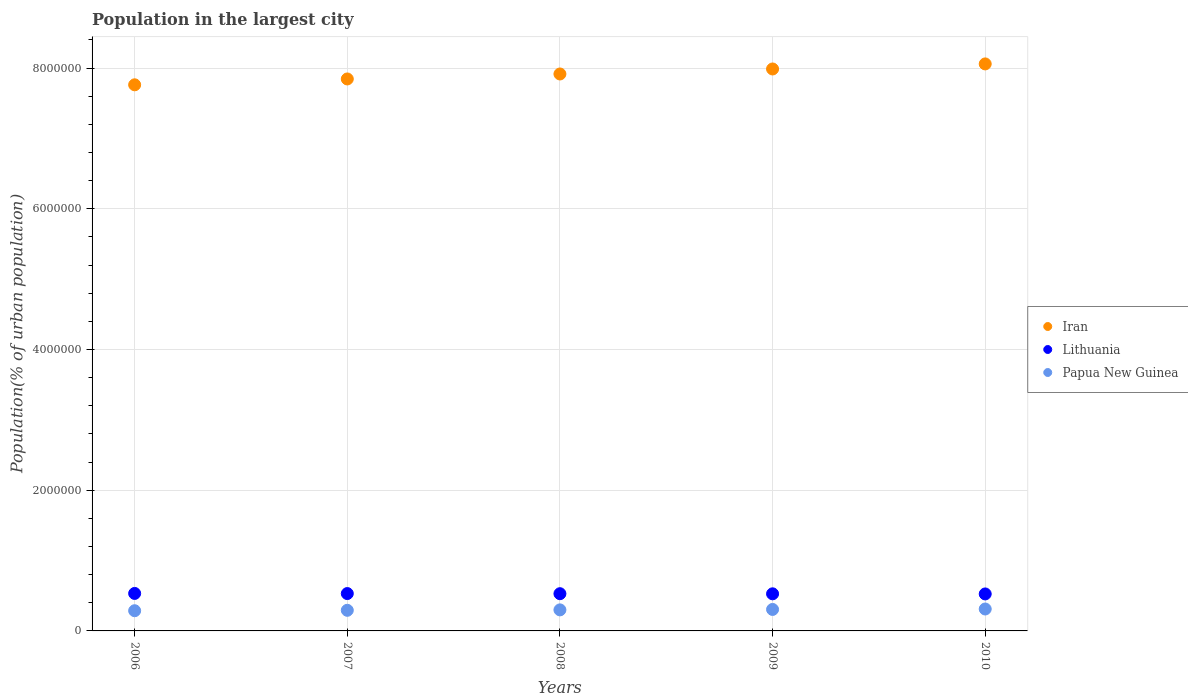Is the number of dotlines equal to the number of legend labels?
Give a very brief answer. Yes. What is the population in the largest city in Lithuania in 2006?
Offer a very short reply. 5.33e+05. Across all years, what is the maximum population in the largest city in Iran?
Offer a terse response. 8.06e+06. Across all years, what is the minimum population in the largest city in Iran?
Your response must be concise. 7.76e+06. In which year was the population in the largest city in Iran maximum?
Give a very brief answer. 2010. In which year was the population in the largest city in Lithuania minimum?
Make the answer very short. 2010. What is the total population in the largest city in Papua New Guinea in the graph?
Offer a very short reply. 1.50e+06. What is the difference between the population in the largest city in Iran in 2007 and that in 2009?
Your response must be concise. -1.42e+05. What is the difference between the population in the largest city in Lithuania in 2006 and the population in the largest city in Iran in 2007?
Provide a short and direct response. -7.31e+06. What is the average population in the largest city in Papua New Guinea per year?
Offer a very short reply. 2.99e+05. In the year 2010, what is the difference between the population in the largest city in Lithuania and population in the largest city in Iran?
Give a very brief answer. -7.53e+06. In how many years, is the population in the largest city in Iran greater than 800000 %?
Make the answer very short. 5. What is the ratio of the population in the largest city in Lithuania in 2009 to that in 2010?
Offer a terse response. 1. Is the population in the largest city in Lithuania in 2008 less than that in 2009?
Provide a succinct answer. No. What is the difference between the highest and the second highest population in the largest city in Lithuania?
Keep it short and to the point. 1802. What is the difference between the highest and the lowest population in the largest city in Papua New Guinea?
Your answer should be very brief. 2.44e+04. Is the sum of the population in the largest city in Lithuania in 2006 and 2009 greater than the maximum population in the largest city in Iran across all years?
Provide a short and direct response. No. Is it the case that in every year, the sum of the population in the largest city in Lithuania and population in the largest city in Iran  is greater than the population in the largest city in Papua New Guinea?
Keep it short and to the point. Yes. Is the population in the largest city in Papua New Guinea strictly less than the population in the largest city in Iran over the years?
Ensure brevity in your answer.  Yes. How many dotlines are there?
Offer a very short reply. 3. What is the difference between two consecutive major ticks on the Y-axis?
Your response must be concise. 2.00e+06. Are the values on the major ticks of Y-axis written in scientific E-notation?
Your answer should be compact. No. Does the graph contain any zero values?
Provide a short and direct response. No. Does the graph contain grids?
Your response must be concise. Yes. How many legend labels are there?
Give a very brief answer. 3. How are the legend labels stacked?
Provide a succinct answer. Vertical. What is the title of the graph?
Make the answer very short. Population in the largest city. Does "Norway" appear as one of the legend labels in the graph?
Your answer should be very brief. No. What is the label or title of the X-axis?
Provide a succinct answer. Years. What is the label or title of the Y-axis?
Your answer should be very brief. Population(% of urban population). What is the Population(% of urban population) of Iran in 2006?
Your answer should be very brief. 7.76e+06. What is the Population(% of urban population) in Lithuania in 2006?
Your answer should be very brief. 5.33e+05. What is the Population(% of urban population) in Papua New Guinea in 2006?
Ensure brevity in your answer.  2.87e+05. What is the Population(% of urban population) of Iran in 2007?
Keep it short and to the point. 7.84e+06. What is the Population(% of urban population) in Lithuania in 2007?
Provide a succinct answer. 5.31e+05. What is the Population(% of urban population) of Papua New Guinea in 2007?
Make the answer very short. 2.93e+05. What is the Population(% of urban population) in Iran in 2008?
Your answer should be very brief. 7.92e+06. What is the Population(% of urban population) of Lithuania in 2008?
Provide a short and direct response. 5.29e+05. What is the Population(% of urban population) of Papua New Guinea in 2008?
Your answer should be very brief. 2.99e+05. What is the Population(% of urban population) of Iran in 2009?
Keep it short and to the point. 7.99e+06. What is the Population(% of urban population) in Lithuania in 2009?
Your answer should be compact. 5.27e+05. What is the Population(% of urban population) of Papua New Guinea in 2009?
Make the answer very short. 3.05e+05. What is the Population(% of urban population) in Iran in 2010?
Provide a short and direct response. 8.06e+06. What is the Population(% of urban population) in Lithuania in 2010?
Your answer should be very brief. 5.26e+05. What is the Population(% of urban population) in Papua New Guinea in 2010?
Make the answer very short. 3.12e+05. Across all years, what is the maximum Population(% of urban population) of Iran?
Offer a very short reply. 8.06e+06. Across all years, what is the maximum Population(% of urban population) in Lithuania?
Give a very brief answer. 5.33e+05. Across all years, what is the maximum Population(% of urban population) of Papua New Guinea?
Your answer should be very brief. 3.12e+05. Across all years, what is the minimum Population(% of urban population) in Iran?
Offer a very short reply. 7.76e+06. Across all years, what is the minimum Population(% of urban population) in Lithuania?
Your answer should be very brief. 5.26e+05. Across all years, what is the minimum Population(% of urban population) in Papua New Guinea?
Keep it short and to the point. 2.87e+05. What is the total Population(% of urban population) in Iran in the graph?
Ensure brevity in your answer.  3.96e+07. What is the total Population(% of urban population) in Lithuania in the graph?
Provide a succinct answer. 2.65e+06. What is the total Population(% of urban population) of Papua New Guinea in the graph?
Your answer should be compact. 1.50e+06. What is the difference between the Population(% of urban population) of Iran in 2006 and that in 2007?
Your answer should be compact. -8.32e+04. What is the difference between the Population(% of urban population) of Lithuania in 2006 and that in 2007?
Offer a very short reply. 1802. What is the difference between the Population(% of urban population) of Papua New Guinea in 2006 and that in 2007?
Provide a succinct answer. -5919. What is the difference between the Population(% of urban population) in Iran in 2006 and that in 2008?
Keep it short and to the point. -1.54e+05. What is the difference between the Population(% of urban population) of Lithuania in 2006 and that in 2008?
Give a very brief answer. 3600. What is the difference between the Population(% of urban population) of Papua New Guinea in 2006 and that in 2008?
Offer a terse response. -1.20e+04. What is the difference between the Population(% of urban population) of Iran in 2006 and that in 2009?
Provide a short and direct response. -2.25e+05. What is the difference between the Population(% of urban population) in Lithuania in 2006 and that in 2009?
Your answer should be very brief. 5387. What is the difference between the Population(% of urban population) of Papua New Guinea in 2006 and that in 2009?
Your response must be concise. -1.81e+04. What is the difference between the Population(% of urban population) in Iran in 2006 and that in 2010?
Make the answer very short. -2.97e+05. What is the difference between the Population(% of urban population) in Lithuania in 2006 and that in 2010?
Keep it short and to the point. 7170. What is the difference between the Population(% of urban population) in Papua New Guinea in 2006 and that in 2010?
Provide a succinct answer. -2.44e+04. What is the difference between the Population(% of urban population) of Iran in 2007 and that in 2008?
Keep it short and to the point. -7.07e+04. What is the difference between the Population(% of urban population) of Lithuania in 2007 and that in 2008?
Your answer should be very brief. 1798. What is the difference between the Population(% of urban population) of Papua New Guinea in 2007 and that in 2008?
Ensure brevity in your answer.  -6050. What is the difference between the Population(% of urban population) of Iran in 2007 and that in 2009?
Your answer should be compact. -1.42e+05. What is the difference between the Population(% of urban population) in Lithuania in 2007 and that in 2009?
Ensure brevity in your answer.  3585. What is the difference between the Population(% of urban population) of Papua New Guinea in 2007 and that in 2009?
Your answer should be very brief. -1.22e+04. What is the difference between the Population(% of urban population) in Iran in 2007 and that in 2010?
Ensure brevity in your answer.  -2.14e+05. What is the difference between the Population(% of urban population) in Lithuania in 2007 and that in 2010?
Give a very brief answer. 5368. What is the difference between the Population(% of urban population) of Papua New Guinea in 2007 and that in 2010?
Give a very brief answer. -1.85e+04. What is the difference between the Population(% of urban population) of Iran in 2008 and that in 2009?
Your response must be concise. -7.12e+04. What is the difference between the Population(% of urban population) of Lithuania in 2008 and that in 2009?
Your response must be concise. 1787. What is the difference between the Population(% of urban population) in Papua New Guinea in 2008 and that in 2009?
Offer a terse response. -6157. What is the difference between the Population(% of urban population) in Iran in 2008 and that in 2010?
Your response must be concise. -1.43e+05. What is the difference between the Population(% of urban population) in Lithuania in 2008 and that in 2010?
Provide a short and direct response. 3570. What is the difference between the Population(% of urban population) of Papua New Guinea in 2008 and that in 2010?
Your answer should be very brief. -1.24e+04. What is the difference between the Population(% of urban population) of Iran in 2009 and that in 2010?
Your answer should be compact. -7.19e+04. What is the difference between the Population(% of urban population) in Lithuania in 2009 and that in 2010?
Keep it short and to the point. 1783. What is the difference between the Population(% of urban population) of Papua New Guinea in 2009 and that in 2010?
Provide a succinct answer. -6293. What is the difference between the Population(% of urban population) of Iran in 2006 and the Population(% of urban population) of Lithuania in 2007?
Offer a terse response. 7.23e+06. What is the difference between the Population(% of urban population) of Iran in 2006 and the Population(% of urban population) of Papua New Guinea in 2007?
Offer a very short reply. 7.47e+06. What is the difference between the Population(% of urban population) of Lithuania in 2006 and the Population(% of urban population) of Papua New Guinea in 2007?
Ensure brevity in your answer.  2.40e+05. What is the difference between the Population(% of urban population) of Iran in 2006 and the Population(% of urban population) of Lithuania in 2008?
Provide a short and direct response. 7.23e+06. What is the difference between the Population(% of urban population) in Iran in 2006 and the Population(% of urban population) in Papua New Guinea in 2008?
Provide a short and direct response. 7.46e+06. What is the difference between the Population(% of urban population) of Lithuania in 2006 and the Population(% of urban population) of Papua New Guinea in 2008?
Your answer should be very brief. 2.34e+05. What is the difference between the Population(% of urban population) in Iran in 2006 and the Population(% of urban population) in Lithuania in 2009?
Keep it short and to the point. 7.23e+06. What is the difference between the Population(% of urban population) of Iran in 2006 and the Population(% of urban population) of Papua New Guinea in 2009?
Offer a terse response. 7.46e+06. What is the difference between the Population(% of urban population) in Lithuania in 2006 and the Population(% of urban population) in Papua New Guinea in 2009?
Offer a very short reply. 2.28e+05. What is the difference between the Population(% of urban population) of Iran in 2006 and the Population(% of urban population) of Lithuania in 2010?
Provide a succinct answer. 7.24e+06. What is the difference between the Population(% of urban population) in Iran in 2006 and the Population(% of urban population) in Papua New Guinea in 2010?
Make the answer very short. 7.45e+06. What is the difference between the Population(% of urban population) of Lithuania in 2006 and the Population(% of urban population) of Papua New Guinea in 2010?
Give a very brief answer. 2.21e+05. What is the difference between the Population(% of urban population) of Iran in 2007 and the Population(% of urban population) of Lithuania in 2008?
Your response must be concise. 7.32e+06. What is the difference between the Population(% of urban population) in Iran in 2007 and the Population(% of urban population) in Papua New Guinea in 2008?
Provide a succinct answer. 7.55e+06. What is the difference between the Population(% of urban population) in Lithuania in 2007 and the Population(% of urban population) in Papua New Guinea in 2008?
Ensure brevity in your answer.  2.32e+05. What is the difference between the Population(% of urban population) of Iran in 2007 and the Population(% of urban population) of Lithuania in 2009?
Provide a short and direct response. 7.32e+06. What is the difference between the Population(% of urban population) of Iran in 2007 and the Population(% of urban population) of Papua New Guinea in 2009?
Offer a terse response. 7.54e+06. What is the difference between the Population(% of urban population) of Lithuania in 2007 and the Population(% of urban population) of Papua New Guinea in 2009?
Your answer should be compact. 2.26e+05. What is the difference between the Population(% of urban population) in Iran in 2007 and the Population(% of urban population) in Lithuania in 2010?
Offer a very short reply. 7.32e+06. What is the difference between the Population(% of urban population) in Iran in 2007 and the Population(% of urban population) in Papua New Guinea in 2010?
Keep it short and to the point. 7.53e+06. What is the difference between the Population(% of urban population) of Lithuania in 2007 and the Population(% of urban population) of Papua New Guinea in 2010?
Your response must be concise. 2.19e+05. What is the difference between the Population(% of urban population) in Iran in 2008 and the Population(% of urban population) in Lithuania in 2009?
Give a very brief answer. 7.39e+06. What is the difference between the Population(% of urban population) of Iran in 2008 and the Population(% of urban population) of Papua New Guinea in 2009?
Provide a succinct answer. 7.61e+06. What is the difference between the Population(% of urban population) in Lithuania in 2008 and the Population(% of urban population) in Papua New Guinea in 2009?
Offer a terse response. 2.24e+05. What is the difference between the Population(% of urban population) of Iran in 2008 and the Population(% of urban population) of Lithuania in 2010?
Ensure brevity in your answer.  7.39e+06. What is the difference between the Population(% of urban population) of Iran in 2008 and the Population(% of urban population) of Papua New Guinea in 2010?
Provide a succinct answer. 7.60e+06. What is the difference between the Population(% of urban population) of Lithuania in 2008 and the Population(% of urban population) of Papua New Guinea in 2010?
Your answer should be very brief. 2.18e+05. What is the difference between the Population(% of urban population) of Iran in 2009 and the Population(% of urban population) of Lithuania in 2010?
Ensure brevity in your answer.  7.46e+06. What is the difference between the Population(% of urban population) in Iran in 2009 and the Population(% of urban population) in Papua New Guinea in 2010?
Provide a succinct answer. 7.68e+06. What is the difference between the Population(% of urban population) in Lithuania in 2009 and the Population(% of urban population) in Papua New Guinea in 2010?
Your answer should be compact. 2.16e+05. What is the average Population(% of urban population) in Iran per year?
Offer a terse response. 7.91e+06. What is the average Population(% of urban population) in Lithuania per year?
Give a very brief answer. 5.29e+05. What is the average Population(% of urban population) of Papua New Guinea per year?
Make the answer very short. 2.99e+05. In the year 2006, what is the difference between the Population(% of urban population) of Iran and Population(% of urban population) of Lithuania?
Provide a succinct answer. 7.23e+06. In the year 2006, what is the difference between the Population(% of urban population) of Iran and Population(% of urban population) of Papua New Guinea?
Your answer should be very brief. 7.47e+06. In the year 2006, what is the difference between the Population(% of urban population) of Lithuania and Population(% of urban population) of Papua New Guinea?
Your answer should be very brief. 2.46e+05. In the year 2007, what is the difference between the Population(% of urban population) of Iran and Population(% of urban population) of Lithuania?
Your answer should be compact. 7.31e+06. In the year 2007, what is the difference between the Population(% of urban population) of Iran and Population(% of urban population) of Papua New Guinea?
Offer a terse response. 7.55e+06. In the year 2007, what is the difference between the Population(% of urban population) of Lithuania and Population(% of urban population) of Papua New Guinea?
Offer a terse response. 2.38e+05. In the year 2008, what is the difference between the Population(% of urban population) of Iran and Population(% of urban population) of Lithuania?
Keep it short and to the point. 7.39e+06. In the year 2008, what is the difference between the Population(% of urban population) in Iran and Population(% of urban population) in Papua New Guinea?
Ensure brevity in your answer.  7.62e+06. In the year 2008, what is the difference between the Population(% of urban population) in Lithuania and Population(% of urban population) in Papua New Guinea?
Offer a terse response. 2.30e+05. In the year 2009, what is the difference between the Population(% of urban population) in Iran and Population(% of urban population) in Lithuania?
Your answer should be very brief. 7.46e+06. In the year 2009, what is the difference between the Population(% of urban population) in Iran and Population(% of urban population) in Papua New Guinea?
Offer a terse response. 7.68e+06. In the year 2009, what is the difference between the Population(% of urban population) in Lithuania and Population(% of urban population) in Papua New Guinea?
Your response must be concise. 2.22e+05. In the year 2010, what is the difference between the Population(% of urban population) of Iran and Population(% of urban population) of Lithuania?
Provide a succinct answer. 7.53e+06. In the year 2010, what is the difference between the Population(% of urban population) in Iran and Population(% of urban population) in Papua New Guinea?
Offer a terse response. 7.75e+06. In the year 2010, what is the difference between the Population(% of urban population) in Lithuania and Population(% of urban population) in Papua New Guinea?
Provide a short and direct response. 2.14e+05. What is the ratio of the Population(% of urban population) of Iran in 2006 to that in 2007?
Make the answer very short. 0.99. What is the ratio of the Population(% of urban population) in Lithuania in 2006 to that in 2007?
Keep it short and to the point. 1. What is the ratio of the Population(% of urban population) of Papua New Guinea in 2006 to that in 2007?
Make the answer very short. 0.98. What is the ratio of the Population(% of urban population) of Iran in 2006 to that in 2008?
Your answer should be very brief. 0.98. What is the ratio of the Population(% of urban population) in Lithuania in 2006 to that in 2008?
Your response must be concise. 1.01. What is the ratio of the Population(% of urban population) in Papua New Guinea in 2006 to that in 2008?
Provide a succinct answer. 0.96. What is the ratio of the Population(% of urban population) in Iran in 2006 to that in 2009?
Your answer should be compact. 0.97. What is the ratio of the Population(% of urban population) in Lithuania in 2006 to that in 2009?
Offer a terse response. 1.01. What is the ratio of the Population(% of urban population) in Papua New Guinea in 2006 to that in 2009?
Keep it short and to the point. 0.94. What is the ratio of the Population(% of urban population) of Iran in 2006 to that in 2010?
Offer a terse response. 0.96. What is the ratio of the Population(% of urban population) in Lithuania in 2006 to that in 2010?
Provide a short and direct response. 1.01. What is the ratio of the Population(% of urban population) of Papua New Guinea in 2006 to that in 2010?
Make the answer very short. 0.92. What is the ratio of the Population(% of urban population) in Iran in 2007 to that in 2008?
Keep it short and to the point. 0.99. What is the ratio of the Population(% of urban population) of Papua New Guinea in 2007 to that in 2008?
Your response must be concise. 0.98. What is the ratio of the Population(% of urban population) of Iran in 2007 to that in 2009?
Offer a terse response. 0.98. What is the ratio of the Population(% of urban population) in Lithuania in 2007 to that in 2009?
Your answer should be compact. 1.01. What is the ratio of the Population(% of urban population) in Iran in 2007 to that in 2010?
Keep it short and to the point. 0.97. What is the ratio of the Population(% of urban population) of Lithuania in 2007 to that in 2010?
Your answer should be compact. 1.01. What is the ratio of the Population(% of urban population) in Papua New Guinea in 2007 to that in 2010?
Give a very brief answer. 0.94. What is the ratio of the Population(% of urban population) of Iran in 2008 to that in 2009?
Make the answer very short. 0.99. What is the ratio of the Population(% of urban population) of Lithuania in 2008 to that in 2009?
Give a very brief answer. 1. What is the ratio of the Population(% of urban population) of Papua New Guinea in 2008 to that in 2009?
Ensure brevity in your answer.  0.98. What is the ratio of the Population(% of urban population) of Iran in 2008 to that in 2010?
Provide a short and direct response. 0.98. What is the ratio of the Population(% of urban population) of Lithuania in 2008 to that in 2010?
Offer a very short reply. 1.01. What is the ratio of the Population(% of urban population) of Papua New Guinea in 2009 to that in 2010?
Give a very brief answer. 0.98. What is the difference between the highest and the second highest Population(% of urban population) of Iran?
Make the answer very short. 7.19e+04. What is the difference between the highest and the second highest Population(% of urban population) of Lithuania?
Your answer should be compact. 1802. What is the difference between the highest and the second highest Population(% of urban population) in Papua New Guinea?
Offer a very short reply. 6293. What is the difference between the highest and the lowest Population(% of urban population) in Iran?
Offer a terse response. 2.97e+05. What is the difference between the highest and the lowest Population(% of urban population) of Lithuania?
Ensure brevity in your answer.  7170. What is the difference between the highest and the lowest Population(% of urban population) in Papua New Guinea?
Your response must be concise. 2.44e+04. 